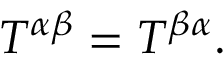Convert formula to latex. <formula><loc_0><loc_0><loc_500><loc_500>T ^ { \alpha \beta } = T ^ { \beta \alpha } .</formula> 